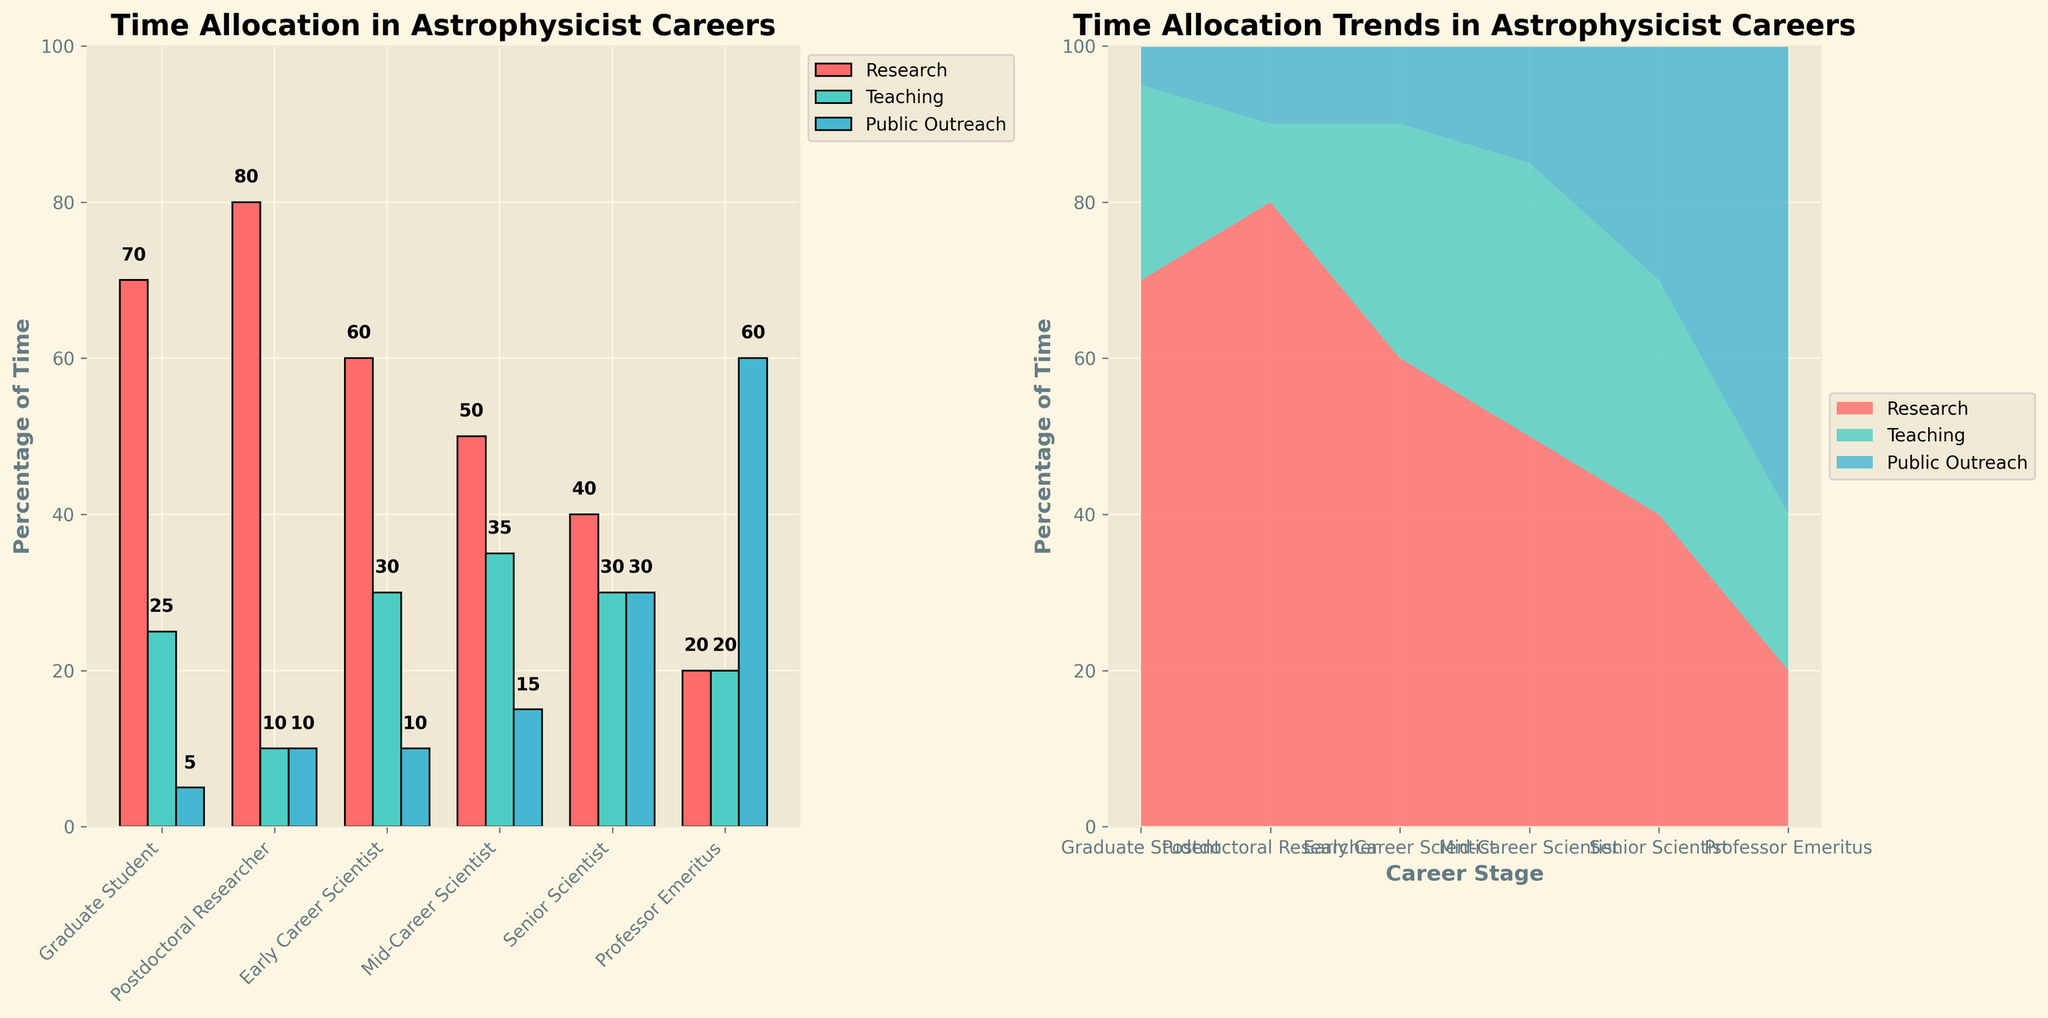What is the highest percentage of time spent on research at any career stage? The bar chart shows the percentage of time spent on research for different career stages, with "Postdoctoral Researcher" having the highest percentage. This can be observed directly from the tallest red bar in the "Research" category.
Answer: 80% How does the time spent on public outreach change from a Mid-Career Scientist to a Professor Emeritus? Compare the heights of the blue bars representing "Public Outreach" for "Mid-Career Scientist" and "Professor Emeritus." The percentage increases from 15% to 60%.
Answer: Increases by 45% What is the total percentage of time dedicated to teaching and public outreach by early career scientists? The percentages for "Teaching" and "Public Outreach" for "Early Career Scientist" are given as 30% and 10%, respectively. Add these two percentages: 30% + 10% = 40%.
Answer: 40% In which career stage do astrophysicists spend an equal percentage of their time on teaching and public outreach? Look for the career stage where the "Teaching" (green) and "Public Outreach" (blue) bars have the same height. This happens at "Professor Emeritus," both at 20%.
Answer: Professor Emeritus Between which two career stages does the percentage of time spent on research show the greatest decrease? Observe the decline in the height of the red bars across career stages. The greatest decrease in "Research" percentage occurs between "Postdoctoral Researcher" (80%) and "Early Career Scientist" (60%).
Answer: Postdoctoral Researcher to Early Career Scientist What percentage of time do senior scientists spend on activities other than research? The percentage of time spent on research by "Senior Scientist" is 40%. Subtract this from 100% to find the time spent on other activities: 100% - 40% = 60%.
Answer: 60% Which activity sees a consistent increase in percentage of time allocation as career stages progress? Look for the activity whose representative color (blue for Public Outreach) shows consistently increasing heights in its bars across the career stages.
Answer: Public Outreach How does the teaching percentage change from a Graduate Student to a Mid-Career Scientist? The "Teaching" percentages are 25% for "Graduate Student" and 35% for "Mid-Career Scientist." The change is 35% - 25% = 10% increase.
Answer: Increases by 10% What is the sum of the percentages for research and public outreach for a Mid-Career Scientist? The "Mid-Career Scientist" spends 50% of their time on research and 15% on public outreach. Summing these: 50% + 15% = 65%.
Answer: 65% Looking at the stacked area chart, at which career stage do all activities cumulatively reach 100%? In a stacked area chart, the sum of all activities at any career stage reaches 100% by default, illustrated by the upper boundary of the stack touching 100% at each career stage.
Answer: All stages 